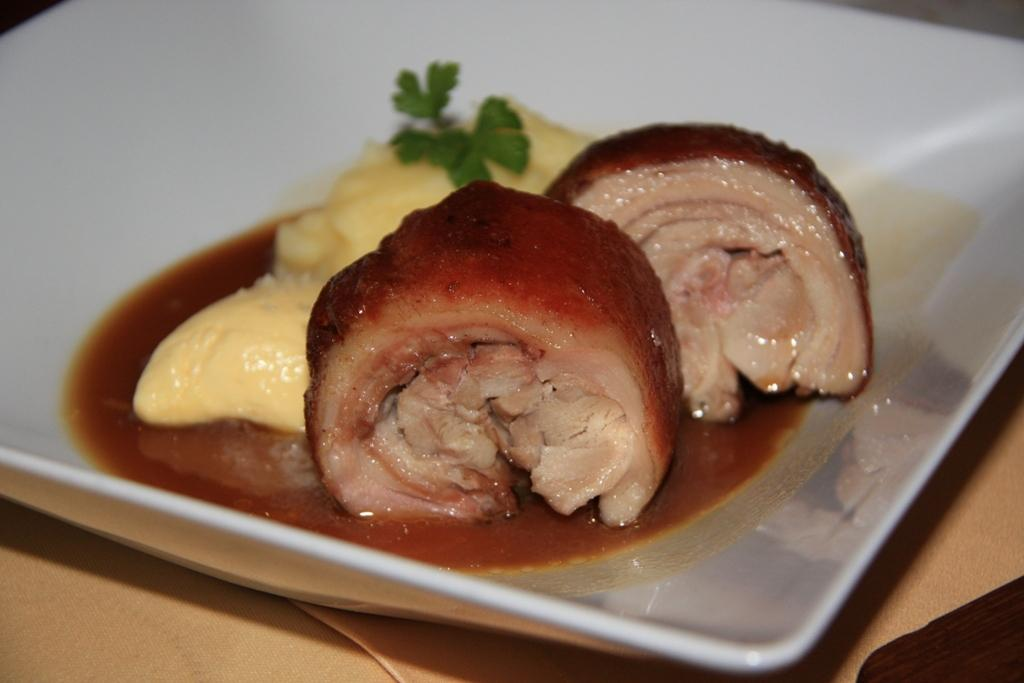What type of food is visible in the image? There is meat in the image. How is the meat presented in the image? The meat is on a plate. What color is the plate? The plate is white. What is covering the table in the image? There is a tablecloth in the image. What is the horse's chance of winning the race in the image? There is no horse or race present in the image; it features meat on a white plate with a tablecloth. 